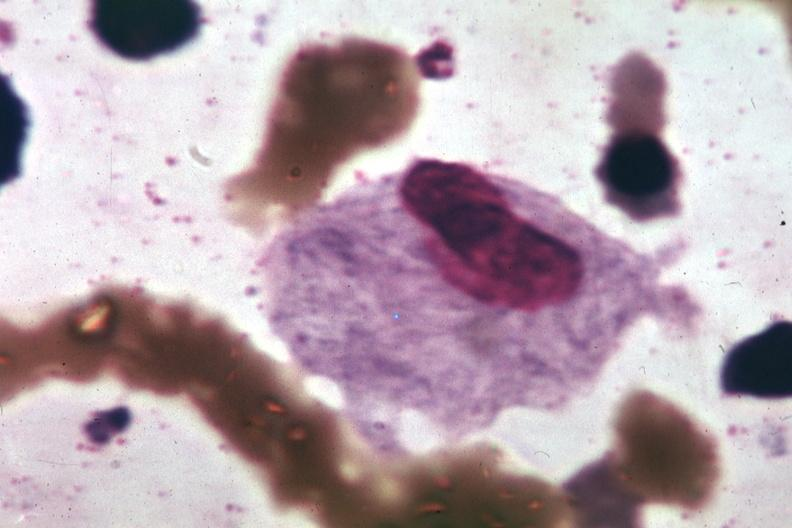does this image show wrights typical cell?
Answer the question using a single word or phrase. Yes 